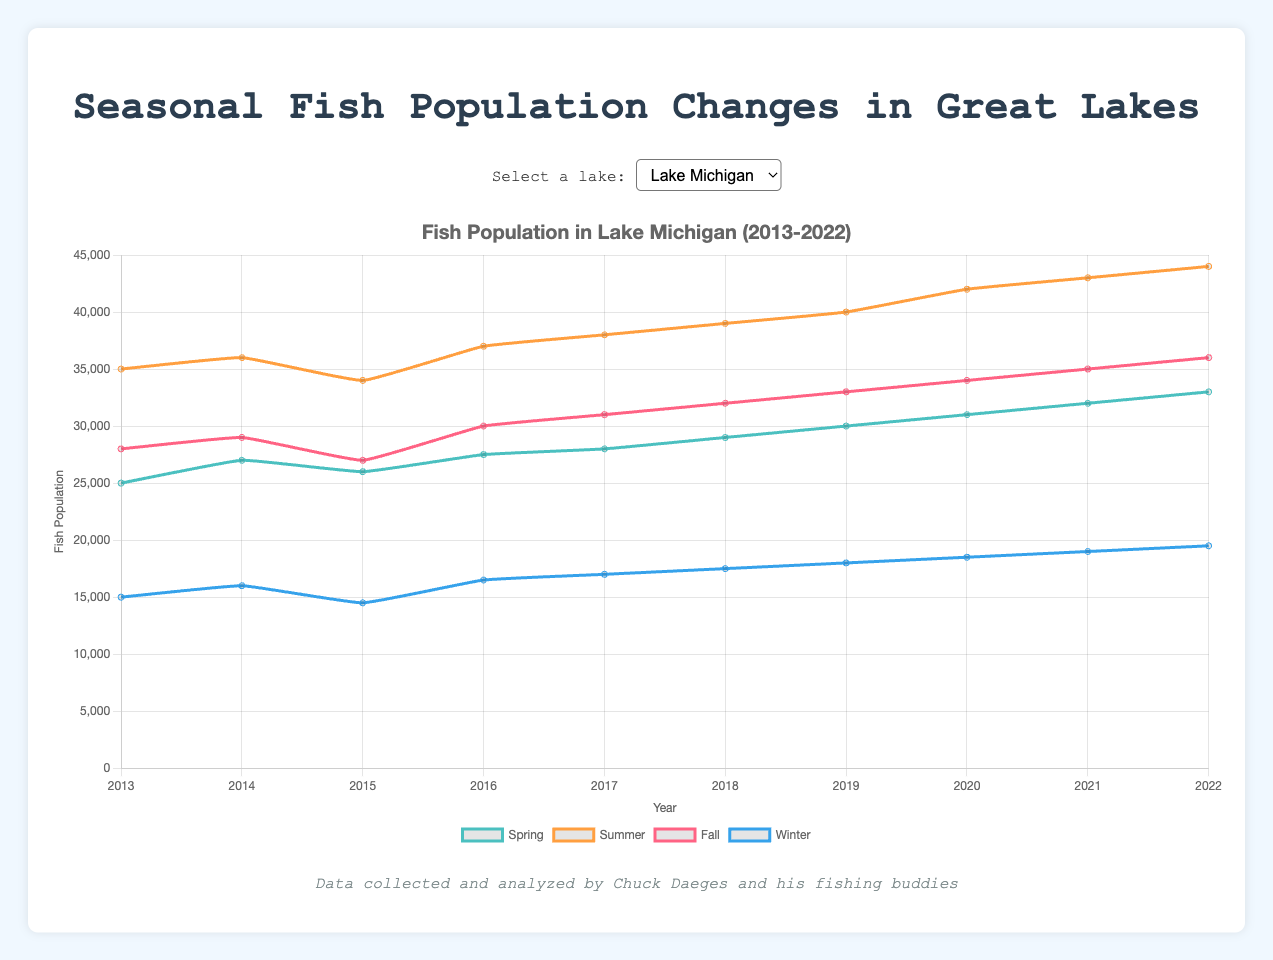What's the fish population difference in Lake Michigan between Summer and Winter for the year 2020? In 2020, the fish population in Lake Michigan was 42000 in Summer and 18500 in Winter. The difference is 42000 - 18500.
Answer: 23500 Which Lake had the highest Spring fish population in 2015? Looking at the Spring fish populations in 2015: Lake Michigan - 26000, Lake Erie - 22000, Lake Huron - 24000, and Lake Ontario - 20000. The highest is 26000 in Lake Michigan.
Answer: Lake Michigan What's the average Fall fish population for Lake Erie across the decade? Sum the Fall populations for Lake Erie from 2013 to 2022 (24000 + 25000 + 25500 + 26000 + 27000 + 28000 + 29000 + 30000 + 31000 + 32000) = 277500. Then, divide by 10.
Answer: 27750 Between 2018 and 2019, which season saw the greatest increase in fish population in Lake Huron? Calculate the difference for each season: Spring (28000 - 27000 = 1000), Summer (39000 - 38000 = 1000), Fall (30000 - 29000 = 1000), Winter (16000 - 15500 = 500). The largest increase is seen in Spring, Summer, and Fall.
Answer: Spring, Summer, Fall In which year did Lake Ontario have the lowest Summer fish population? Comparing the Summer populations in each year: 2013 (27000), 2014 (28000), 2015 (29000), 2016 (30000), 2017 (31000), 2018 (32000), 2019 (33000), 2020 (34000), 2021 (35000), 2022 (36000). The lowest is in 2013.
Answer: 2013 How did the Winter fish population change in Lake Erie from 2013 to 2022? The Winter population in Lake Erie increased from 2013 (12000) to 2022 (16500). The difference is 16500 - 12000.
Answer: +4500 Which season's fish population has the highest value in the plot for Lake Huron? Looking at the highest values in each season for Lake Huron: Spring (31000 in 2022), Summer (42000 in 2022), Fall (33000 in 2022), Winter (17500 in 2022). The highest value is in Summer.
Answer: Summer Among the given lakes, which one shows the most consistent increase in fish population over the decade? Comparing the fish population trends for all lakes, each lake generally shows an increasing trend. However, Lake Michigan shows the most consistent increase across all seasons.
Answer: Lake Michigan 